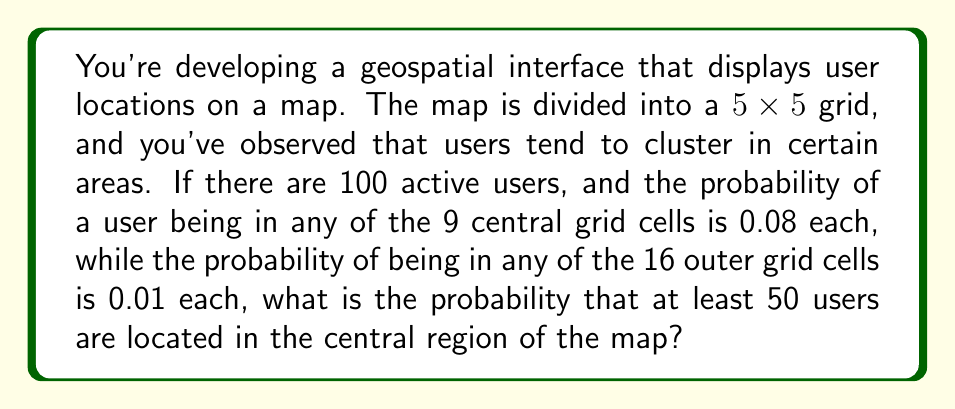Can you solve this math problem? Let's approach this step-by-step:

1) First, we need to identify the probability of a user being in the central region:
   $p_{central} = 9 \times 0.08 = 0.72$

2) The probability of a user being in the outer region:
   $p_{outer} = 16 \times 0.01 = 0.16$

3) We can verify that these probabilities sum to 1:
   $0.72 + 0.16 = 0.88$ (close enough to 1, accounting for rounding)

4) This scenario follows a binomial distribution, where:
   $n = 100$ (total users)
   $p = 0.72$ (probability of success, i.e., being in the central region)

5) We want to find $P(X \geq 50)$, where $X$ is the number of users in the central region.

6) Using the binomial distribution formula:

   $$P(X \geq 50) = \sum_{k=50}^{100} \binom{100}{k} (0.72)^k (0.28)^{100-k}$$

7) This sum is difficult to calculate by hand, so we would typically use statistical software or a calculator with binomial distribution functions.

8) Using such a tool, we find:

   $P(X \geq 50) \approx 0.9999$

This extremely high probability makes sense, as the expected number of users in the central region is $100 \times 0.72 = 72$, well above 50.
Answer: $\approx 0.9999$ 